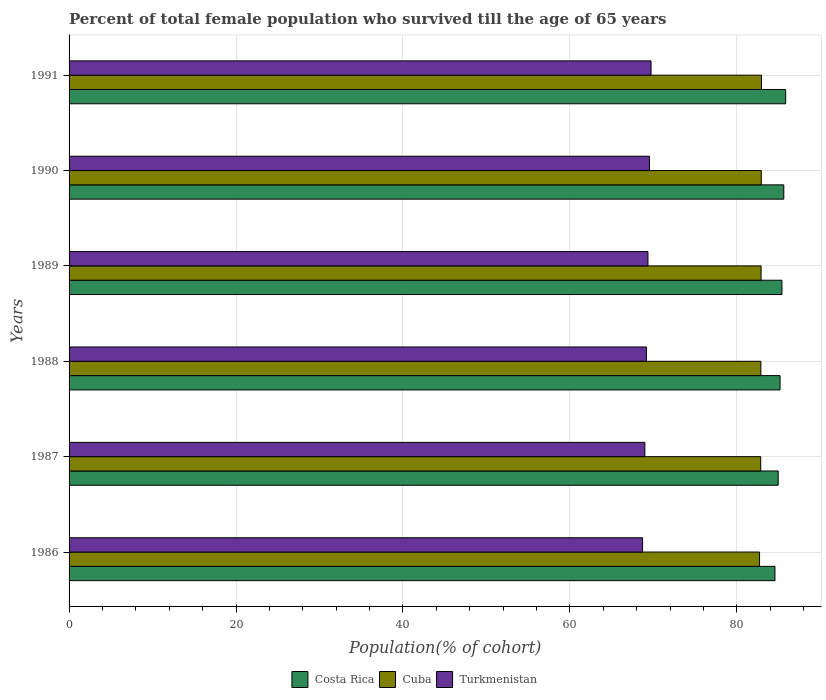How many bars are there on the 4th tick from the bottom?
Your answer should be compact. 3. In how many cases, is the number of bars for a given year not equal to the number of legend labels?
Ensure brevity in your answer.  0. What is the percentage of total female population who survived till the age of 65 years in Turkmenistan in 1988?
Make the answer very short. 69.17. Across all years, what is the maximum percentage of total female population who survived till the age of 65 years in Costa Rica?
Your answer should be compact. 85.85. Across all years, what is the minimum percentage of total female population who survived till the age of 65 years in Costa Rica?
Your response must be concise. 84.57. What is the total percentage of total female population who survived till the age of 65 years in Cuba in the graph?
Offer a terse response. 497.26. What is the difference between the percentage of total female population who survived till the age of 65 years in Turkmenistan in 1986 and that in 1988?
Ensure brevity in your answer.  -0.46. What is the difference between the percentage of total female population who survived till the age of 65 years in Turkmenistan in 1987 and the percentage of total female population who survived till the age of 65 years in Costa Rica in 1989?
Keep it short and to the point. -16.42. What is the average percentage of total female population who survived till the age of 65 years in Costa Rica per year?
Ensure brevity in your answer.  85.27. In the year 1988, what is the difference between the percentage of total female population who survived till the age of 65 years in Turkmenistan and percentage of total female population who survived till the age of 65 years in Cuba?
Your answer should be very brief. -13.72. What is the ratio of the percentage of total female population who survived till the age of 65 years in Cuba in 1986 to that in 1990?
Provide a short and direct response. 1. What is the difference between the highest and the second highest percentage of total female population who survived till the age of 65 years in Costa Rica?
Provide a succinct answer. 0.22. What is the difference between the highest and the lowest percentage of total female population who survived till the age of 65 years in Cuba?
Give a very brief answer. 0.23. In how many years, is the percentage of total female population who survived till the age of 65 years in Turkmenistan greater than the average percentage of total female population who survived till the age of 65 years in Turkmenistan taken over all years?
Keep it short and to the point. 3. What does the 2nd bar from the top in 1987 represents?
Your answer should be compact. Cuba. What does the 3rd bar from the bottom in 1990 represents?
Your response must be concise. Turkmenistan. Is it the case that in every year, the sum of the percentage of total female population who survived till the age of 65 years in Turkmenistan and percentage of total female population who survived till the age of 65 years in Costa Rica is greater than the percentage of total female population who survived till the age of 65 years in Cuba?
Keep it short and to the point. Yes. How many bars are there?
Give a very brief answer. 18. Does the graph contain any zero values?
Provide a short and direct response. No. Where does the legend appear in the graph?
Offer a terse response. Bottom center. How are the legend labels stacked?
Offer a very short reply. Horizontal. What is the title of the graph?
Your answer should be very brief. Percent of total female population who survived till the age of 65 years. What is the label or title of the X-axis?
Keep it short and to the point. Population(% of cohort). What is the label or title of the Y-axis?
Make the answer very short. Years. What is the Population(% of cohort) in Costa Rica in 1986?
Ensure brevity in your answer.  84.57. What is the Population(% of cohort) in Cuba in 1986?
Keep it short and to the point. 82.72. What is the Population(% of cohort) in Turkmenistan in 1986?
Keep it short and to the point. 68.71. What is the Population(% of cohort) of Costa Rica in 1987?
Give a very brief answer. 84.96. What is the Population(% of cohort) of Cuba in 1987?
Your answer should be very brief. 82.86. What is the Population(% of cohort) of Turkmenistan in 1987?
Make the answer very short. 68.98. What is the Population(% of cohort) of Costa Rica in 1988?
Keep it short and to the point. 85.18. What is the Population(% of cohort) in Cuba in 1988?
Provide a succinct answer. 82.89. What is the Population(% of cohort) of Turkmenistan in 1988?
Your answer should be very brief. 69.17. What is the Population(% of cohort) of Costa Rica in 1989?
Your response must be concise. 85.41. What is the Population(% of cohort) in Cuba in 1989?
Ensure brevity in your answer.  82.91. What is the Population(% of cohort) in Turkmenistan in 1989?
Give a very brief answer. 69.35. What is the Population(% of cohort) of Costa Rica in 1990?
Your response must be concise. 85.63. What is the Population(% of cohort) of Cuba in 1990?
Give a very brief answer. 82.93. What is the Population(% of cohort) in Turkmenistan in 1990?
Your answer should be compact. 69.54. What is the Population(% of cohort) in Costa Rica in 1991?
Make the answer very short. 85.85. What is the Population(% of cohort) in Cuba in 1991?
Provide a short and direct response. 82.95. What is the Population(% of cohort) of Turkmenistan in 1991?
Offer a terse response. 69.72. Across all years, what is the maximum Population(% of cohort) of Costa Rica?
Keep it short and to the point. 85.85. Across all years, what is the maximum Population(% of cohort) in Cuba?
Provide a short and direct response. 82.95. Across all years, what is the maximum Population(% of cohort) in Turkmenistan?
Your answer should be compact. 69.72. Across all years, what is the minimum Population(% of cohort) of Costa Rica?
Your answer should be compact. 84.57. Across all years, what is the minimum Population(% of cohort) in Cuba?
Provide a succinct answer. 82.72. Across all years, what is the minimum Population(% of cohort) of Turkmenistan?
Ensure brevity in your answer.  68.71. What is the total Population(% of cohort) of Costa Rica in the graph?
Give a very brief answer. 511.6. What is the total Population(% of cohort) in Cuba in the graph?
Make the answer very short. 497.26. What is the total Population(% of cohort) in Turkmenistan in the graph?
Your response must be concise. 415.48. What is the difference between the Population(% of cohort) in Costa Rica in 1986 and that in 1987?
Provide a succinct answer. -0.39. What is the difference between the Population(% of cohort) of Cuba in 1986 and that in 1987?
Your answer should be very brief. -0.14. What is the difference between the Population(% of cohort) of Turkmenistan in 1986 and that in 1987?
Provide a succinct answer. -0.27. What is the difference between the Population(% of cohort) in Costa Rica in 1986 and that in 1988?
Make the answer very short. -0.61. What is the difference between the Population(% of cohort) of Cuba in 1986 and that in 1988?
Give a very brief answer. -0.16. What is the difference between the Population(% of cohort) in Turkmenistan in 1986 and that in 1988?
Your answer should be compact. -0.46. What is the difference between the Population(% of cohort) in Costa Rica in 1986 and that in 1989?
Provide a succinct answer. -0.84. What is the difference between the Population(% of cohort) of Cuba in 1986 and that in 1989?
Provide a short and direct response. -0.18. What is the difference between the Population(% of cohort) in Turkmenistan in 1986 and that in 1989?
Ensure brevity in your answer.  -0.64. What is the difference between the Population(% of cohort) in Costa Rica in 1986 and that in 1990?
Offer a very short reply. -1.06. What is the difference between the Population(% of cohort) of Cuba in 1986 and that in 1990?
Give a very brief answer. -0.21. What is the difference between the Population(% of cohort) in Turkmenistan in 1986 and that in 1990?
Provide a succinct answer. -0.83. What is the difference between the Population(% of cohort) of Costa Rica in 1986 and that in 1991?
Keep it short and to the point. -1.28. What is the difference between the Population(% of cohort) of Cuba in 1986 and that in 1991?
Your answer should be very brief. -0.23. What is the difference between the Population(% of cohort) in Turkmenistan in 1986 and that in 1991?
Provide a short and direct response. -1.01. What is the difference between the Population(% of cohort) of Costa Rica in 1987 and that in 1988?
Provide a succinct answer. -0.22. What is the difference between the Population(% of cohort) in Cuba in 1987 and that in 1988?
Your answer should be very brief. -0.02. What is the difference between the Population(% of cohort) of Turkmenistan in 1987 and that in 1988?
Offer a very short reply. -0.19. What is the difference between the Population(% of cohort) of Costa Rica in 1987 and that in 1989?
Provide a succinct answer. -0.45. What is the difference between the Population(% of cohort) of Cuba in 1987 and that in 1989?
Offer a very short reply. -0.05. What is the difference between the Population(% of cohort) of Turkmenistan in 1987 and that in 1989?
Ensure brevity in your answer.  -0.37. What is the difference between the Population(% of cohort) in Costa Rica in 1987 and that in 1990?
Offer a terse response. -0.67. What is the difference between the Population(% of cohort) of Cuba in 1987 and that in 1990?
Give a very brief answer. -0.07. What is the difference between the Population(% of cohort) in Turkmenistan in 1987 and that in 1990?
Provide a short and direct response. -0.56. What is the difference between the Population(% of cohort) in Costa Rica in 1987 and that in 1991?
Your answer should be compact. -0.89. What is the difference between the Population(% of cohort) of Cuba in 1987 and that in 1991?
Your response must be concise. -0.09. What is the difference between the Population(% of cohort) in Turkmenistan in 1987 and that in 1991?
Ensure brevity in your answer.  -0.74. What is the difference between the Population(% of cohort) of Costa Rica in 1988 and that in 1989?
Ensure brevity in your answer.  -0.22. What is the difference between the Population(% of cohort) in Cuba in 1988 and that in 1989?
Offer a very short reply. -0.02. What is the difference between the Population(% of cohort) in Turkmenistan in 1988 and that in 1989?
Your response must be concise. -0.19. What is the difference between the Population(% of cohort) in Costa Rica in 1988 and that in 1990?
Ensure brevity in your answer.  -0.45. What is the difference between the Population(% of cohort) in Cuba in 1988 and that in 1990?
Your response must be concise. -0.05. What is the difference between the Population(% of cohort) in Turkmenistan in 1988 and that in 1990?
Make the answer very short. -0.37. What is the difference between the Population(% of cohort) of Costa Rica in 1988 and that in 1991?
Offer a very short reply. -0.67. What is the difference between the Population(% of cohort) in Cuba in 1988 and that in 1991?
Provide a short and direct response. -0.07. What is the difference between the Population(% of cohort) in Turkmenistan in 1988 and that in 1991?
Provide a short and direct response. -0.56. What is the difference between the Population(% of cohort) in Costa Rica in 1989 and that in 1990?
Give a very brief answer. -0.22. What is the difference between the Population(% of cohort) of Cuba in 1989 and that in 1990?
Offer a terse response. -0.02. What is the difference between the Population(% of cohort) in Turkmenistan in 1989 and that in 1990?
Provide a short and direct response. -0.19. What is the difference between the Population(% of cohort) of Costa Rica in 1989 and that in 1991?
Your answer should be compact. -0.45. What is the difference between the Population(% of cohort) in Cuba in 1989 and that in 1991?
Your answer should be compact. -0.05. What is the difference between the Population(% of cohort) in Turkmenistan in 1989 and that in 1991?
Provide a short and direct response. -0.37. What is the difference between the Population(% of cohort) of Costa Rica in 1990 and that in 1991?
Offer a terse response. -0.22. What is the difference between the Population(% of cohort) in Cuba in 1990 and that in 1991?
Offer a very short reply. -0.02. What is the difference between the Population(% of cohort) in Turkmenistan in 1990 and that in 1991?
Make the answer very short. -0.19. What is the difference between the Population(% of cohort) of Costa Rica in 1986 and the Population(% of cohort) of Cuba in 1987?
Keep it short and to the point. 1.71. What is the difference between the Population(% of cohort) of Costa Rica in 1986 and the Population(% of cohort) of Turkmenistan in 1987?
Provide a succinct answer. 15.59. What is the difference between the Population(% of cohort) in Cuba in 1986 and the Population(% of cohort) in Turkmenistan in 1987?
Give a very brief answer. 13.74. What is the difference between the Population(% of cohort) of Costa Rica in 1986 and the Population(% of cohort) of Cuba in 1988?
Provide a succinct answer. 1.69. What is the difference between the Population(% of cohort) in Costa Rica in 1986 and the Population(% of cohort) in Turkmenistan in 1988?
Your answer should be compact. 15.4. What is the difference between the Population(% of cohort) in Cuba in 1986 and the Population(% of cohort) in Turkmenistan in 1988?
Offer a very short reply. 13.56. What is the difference between the Population(% of cohort) in Costa Rica in 1986 and the Population(% of cohort) in Cuba in 1989?
Your answer should be compact. 1.66. What is the difference between the Population(% of cohort) in Costa Rica in 1986 and the Population(% of cohort) in Turkmenistan in 1989?
Your response must be concise. 15.22. What is the difference between the Population(% of cohort) of Cuba in 1986 and the Population(% of cohort) of Turkmenistan in 1989?
Keep it short and to the point. 13.37. What is the difference between the Population(% of cohort) in Costa Rica in 1986 and the Population(% of cohort) in Cuba in 1990?
Your response must be concise. 1.64. What is the difference between the Population(% of cohort) of Costa Rica in 1986 and the Population(% of cohort) of Turkmenistan in 1990?
Your answer should be very brief. 15.03. What is the difference between the Population(% of cohort) in Cuba in 1986 and the Population(% of cohort) in Turkmenistan in 1990?
Make the answer very short. 13.18. What is the difference between the Population(% of cohort) of Costa Rica in 1986 and the Population(% of cohort) of Cuba in 1991?
Give a very brief answer. 1.62. What is the difference between the Population(% of cohort) in Costa Rica in 1986 and the Population(% of cohort) in Turkmenistan in 1991?
Keep it short and to the point. 14.85. What is the difference between the Population(% of cohort) in Cuba in 1986 and the Population(% of cohort) in Turkmenistan in 1991?
Offer a terse response. 13. What is the difference between the Population(% of cohort) of Costa Rica in 1987 and the Population(% of cohort) of Cuba in 1988?
Your response must be concise. 2.07. What is the difference between the Population(% of cohort) of Costa Rica in 1987 and the Population(% of cohort) of Turkmenistan in 1988?
Provide a short and direct response. 15.79. What is the difference between the Population(% of cohort) in Cuba in 1987 and the Population(% of cohort) in Turkmenistan in 1988?
Offer a terse response. 13.69. What is the difference between the Population(% of cohort) in Costa Rica in 1987 and the Population(% of cohort) in Cuba in 1989?
Make the answer very short. 2.05. What is the difference between the Population(% of cohort) in Costa Rica in 1987 and the Population(% of cohort) in Turkmenistan in 1989?
Your answer should be very brief. 15.61. What is the difference between the Population(% of cohort) in Cuba in 1987 and the Population(% of cohort) in Turkmenistan in 1989?
Your response must be concise. 13.51. What is the difference between the Population(% of cohort) of Costa Rica in 1987 and the Population(% of cohort) of Cuba in 1990?
Make the answer very short. 2.03. What is the difference between the Population(% of cohort) in Costa Rica in 1987 and the Population(% of cohort) in Turkmenistan in 1990?
Make the answer very short. 15.42. What is the difference between the Population(% of cohort) of Cuba in 1987 and the Population(% of cohort) of Turkmenistan in 1990?
Provide a short and direct response. 13.32. What is the difference between the Population(% of cohort) of Costa Rica in 1987 and the Population(% of cohort) of Cuba in 1991?
Make the answer very short. 2. What is the difference between the Population(% of cohort) in Costa Rica in 1987 and the Population(% of cohort) in Turkmenistan in 1991?
Your response must be concise. 15.23. What is the difference between the Population(% of cohort) of Cuba in 1987 and the Population(% of cohort) of Turkmenistan in 1991?
Keep it short and to the point. 13.14. What is the difference between the Population(% of cohort) of Costa Rica in 1988 and the Population(% of cohort) of Cuba in 1989?
Offer a very short reply. 2.27. What is the difference between the Population(% of cohort) in Costa Rica in 1988 and the Population(% of cohort) in Turkmenistan in 1989?
Your answer should be very brief. 15.83. What is the difference between the Population(% of cohort) of Cuba in 1988 and the Population(% of cohort) of Turkmenistan in 1989?
Your response must be concise. 13.53. What is the difference between the Population(% of cohort) of Costa Rica in 1988 and the Population(% of cohort) of Cuba in 1990?
Your answer should be compact. 2.25. What is the difference between the Population(% of cohort) in Costa Rica in 1988 and the Population(% of cohort) in Turkmenistan in 1990?
Your response must be concise. 15.64. What is the difference between the Population(% of cohort) of Cuba in 1988 and the Population(% of cohort) of Turkmenistan in 1990?
Offer a terse response. 13.35. What is the difference between the Population(% of cohort) in Costa Rica in 1988 and the Population(% of cohort) in Cuba in 1991?
Provide a succinct answer. 2.23. What is the difference between the Population(% of cohort) of Costa Rica in 1988 and the Population(% of cohort) of Turkmenistan in 1991?
Offer a terse response. 15.46. What is the difference between the Population(% of cohort) of Cuba in 1988 and the Population(% of cohort) of Turkmenistan in 1991?
Ensure brevity in your answer.  13.16. What is the difference between the Population(% of cohort) in Costa Rica in 1989 and the Population(% of cohort) in Cuba in 1990?
Your answer should be compact. 2.47. What is the difference between the Population(% of cohort) of Costa Rica in 1989 and the Population(% of cohort) of Turkmenistan in 1990?
Provide a short and direct response. 15.87. What is the difference between the Population(% of cohort) of Cuba in 1989 and the Population(% of cohort) of Turkmenistan in 1990?
Keep it short and to the point. 13.37. What is the difference between the Population(% of cohort) in Costa Rica in 1989 and the Population(% of cohort) in Cuba in 1991?
Offer a very short reply. 2.45. What is the difference between the Population(% of cohort) in Costa Rica in 1989 and the Population(% of cohort) in Turkmenistan in 1991?
Offer a terse response. 15.68. What is the difference between the Population(% of cohort) of Cuba in 1989 and the Population(% of cohort) of Turkmenistan in 1991?
Make the answer very short. 13.18. What is the difference between the Population(% of cohort) in Costa Rica in 1990 and the Population(% of cohort) in Cuba in 1991?
Keep it short and to the point. 2.68. What is the difference between the Population(% of cohort) of Costa Rica in 1990 and the Population(% of cohort) of Turkmenistan in 1991?
Give a very brief answer. 15.9. What is the difference between the Population(% of cohort) of Cuba in 1990 and the Population(% of cohort) of Turkmenistan in 1991?
Your answer should be compact. 13.21. What is the average Population(% of cohort) in Costa Rica per year?
Your response must be concise. 85.27. What is the average Population(% of cohort) of Cuba per year?
Offer a very short reply. 82.88. What is the average Population(% of cohort) of Turkmenistan per year?
Provide a succinct answer. 69.25. In the year 1986, what is the difference between the Population(% of cohort) in Costa Rica and Population(% of cohort) in Cuba?
Offer a very short reply. 1.85. In the year 1986, what is the difference between the Population(% of cohort) in Costa Rica and Population(% of cohort) in Turkmenistan?
Ensure brevity in your answer.  15.86. In the year 1986, what is the difference between the Population(% of cohort) in Cuba and Population(% of cohort) in Turkmenistan?
Ensure brevity in your answer.  14.01. In the year 1987, what is the difference between the Population(% of cohort) in Costa Rica and Population(% of cohort) in Cuba?
Give a very brief answer. 2.1. In the year 1987, what is the difference between the Population(% of cohort) of Costa Rica and Population(% of cohort) of Turkmenistan?
Give a very brief answer. 15.98. In the year 1987, what is the difference between the Population(% of cohort) of Cuba and Population(% of cohort) of Turkmenistan?
Offer a very short reply. 13.88. In the year 1988, what is the difference between the Population(% of cohort) in Costa Rica and Population(% of cohort) in Cuba?
Offer a terse response. 2.3. In the year 1988, what is the difference between the Population(% of cohort) of Costa Rica and Population(% of cohort) of Turkmenistan?
Give a very brief answer. 16.01. In the year 1988, what is the difference between the Population(% of cohort) in Cuba and Population(% of cohort) in Turkmenistan?
Give a very brief answer. 13.72. In the year 1989, what is the difference between the Population(% of cohort) in Costa Rica and Population(% of cohort) in Cuba?
Your answer should be very brief. 2.5. In the year 1989, what is the difference between the Population(% of cohort) of Costa Rica and Population(% of cohort) of Turkmenistan?
Provide a succinct answer. 16.05. In the year 1989, what is the difference between the Population(% of cohort) of Cuba and Population(% of cohort) of Turkmenistan?
Give a very brief answer. 13.55. In the year 1990, what is the difference between the Population(% of cohort) in Costa Rica and Population(% of cohort) in Cuba?
Ensure brevity in your answer.  2.7. In the year 1990, what is the difference between the Population(% of cohort) in Costa Rica and Population(% of cohort) in Turkmenistan?
Offer a very short reply. 16.09. In the year 1990, what is the difference between the Population(% of cohort) of Cuba and Population(% of cohort) of Turkmenistan?
Provide a succinct answer. 13.39. In the year 1991, what is the difference between the Population(% of cohort) in Costa Rica and Population(% of cohort) in Cuba?
Give a very brief answer. 2.9. In the year 1991, what is the difference between the Population(% of cohort) in Costa Rica and Population(% of cohort) in Turkmenistan?
Your answer should be compact. 16.13. In the year 1991, what is the difference between the Population(% of cohort) in Cuba and Population(% of cohort) in Turkmenistan?
Give a very brief answer. 13.23. What is the ratio of the Population(% of cohort) of Turkmenistan in 1986 to that in 1987?
Provide a short and direct response. 1. What is the ratio of the Population(% of cohort) of Turkmenistan in 1986 to that in 1988?
Provide a succinct answer. 0.99. What is the ratio of the Population(% of cohort) in Costa Rica in 1986 to that in 1989?
Keep it short and to the point. 0.99. What is the ratio of the Population(% of cohort) in Cuba in 1986 to that in 1989?
Offer a terse response. 1. What is the ratio of the Population(% of cohort) of Costa Rica in 1986 to that in 1990?
Your answer should be very brief. 0.99. What is the ratio of the Population(% of cohort) of Turkmenistan in 1986 to that in 1990?
Your response must be concise. 0.99. What is the ratio of the Population(% of cohort) in Costa Rica in 1986 to that in 1991?
Provide a short and direct response. 0.99. What is the ratio of the Population(% of cohort) of Turkmenistan in 1986 to that in 1991?
Give a very brief answer. 0.99. What is the ratio of the Population(% of cohort) of Costa Rica in 1987 to that in 1988?
Offer a terse response. 1. What is the ratio of the Population(% of cohort) in Cuba in 1987 to that in 1988?
Provide a short and direct response. 1. What is the ratio of the Population(% of cohort) of Costa Rica in 1987 to that in 1989?
Keep it short and to the point. 0.99. What is the ratio of the Population(% of cohort) in Cuba in 1987 to that in 1989?
Give a very brief answer. 1. What is the ratio of the Population(% of cohort) of Turkmenistan in 1987 to that in 1990?
Keep it short and to the point. 0.99. What is the ratio of the Population(% of cohort) of Costa Rica in 1987 to that in 1991?
Your answer should be compact. 0.99. What is the ratio of the Population(% of cohort) of Turkmenistan in 1987 to that in 1991?
Provide a succinct answer. 0.99. What is the ratio of the Population(% of cohort) in Costa Rica in 1988 to that in 1989?
Make the answer very short. 1. What is the ratio of the Population(% of cohort) in Costa Rica in 1988 to that in 1990?
Offer a very short reply. 0.99. What is the ratio of the Population(% of cohort) in Cuba in 1988 to that in 1990?
Provide a short and direct response. 1. What is the ratio of the Population(% of cohort) of Costa Rica in 1988 to that in 1991?
Provide a short and direct response. 0.99. What is the ratio of the Population(% of cohort) of Cuba in 1988 to that in 1991?
Your response must be concise. 1. What is the ratio of the Population(% of cohort) of Cuba in 1989 to that in 1990?
Your answer should be very brief. 1. What is the ratio of the Population(% of cohort) in Turkmenistan in 1989 to that in 1990?
Provide a short and direct response. 1. What is the ratio of the Population(% of cohort) of Costa Rica in 1989 to that in 1991?
Offer a very short reply. 0.99. What is the ratio of the Population(% of cohort) of Cuba in 1989 to that in 1991?
Your answer should be compact. 1. What is the ratio of the Population(% of cohort) in Turkmenistan in 1989 to that in 1991?
Make the answer very short. 0.99. What is the ratio of the Population(% of cohort) in Costa Rica in 1990 to that in 1991?
Your answer should be very brief. 1. What is the ratio of the Population(% of cohort) in Cuba in 1990 to that in 1991?
Your answer should be compact. 1. What is the ratio of the Population(% of cohort) in Turkmenistan in 1990 to that in 1991?
Offer a terse response. 1. What is the difference between the highest and the second highest Population(% of cohort) of Costa Rica?
Keep it short and to the point. 0.22. What is the difference between the highest and the second highest Population(% of cohort) in Cuba?
Provide a short and direct response. 0.02. What is the difference between the highest and the second highest Population(% of cohort) in Turkmenistan?
Make the answer very short. 0.19. What is the difference between the highest and the lowest Population(% of cohort) in Costa Rica?
Offer a very short reply. 1.28. What is the difference between the highest and the lowest Population(% of cohort) in Cuba?
Your response must be concise. 0.23. What is the difference between the highest and the lowest Population(% of cohort) of Turkmenistan?
Keep it short and to the point. 1.01. 